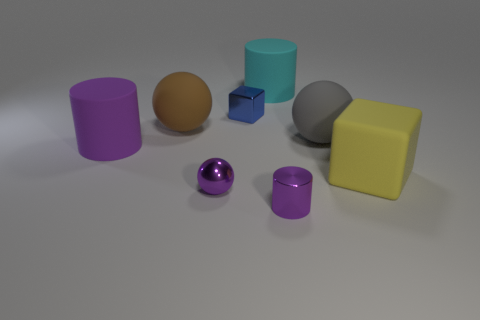Are there an equal number of tiny metal cylinders that are behind the small purple sphere and large gray shiny cubes?
Your answer should be compact. Yes. What number of blocks are behind the ball that is right of the tiny thing right of the small blue metallic thing?
Keep it short and to the point. 1. There is a brown rubber thing; is it the same size as the matte cylinder behind the blue cube?
Your answer should be very brief. Yes. What number of matte spheres are there?
Your response must be concise. 2. There is a purple cylinder right of the blue object; does it have the same size as the metal object behind the large yellow thing?
Make the answer very short. Yes. What is the color of the small thing that is the same shape as the big purple thing?
Ensure brevity in your answer.  Purple. Does the yellow matte thing have the same shape as the brown object?
Offer a very short reply. No. There is a rubber thing that is the same shape as the blue metallic thing; what size is it?
Offer a very short reply. Large. How many large gray spheres have the same material as the large gray thing?
Offer a very short reply. 0. What number of things are large matte cubes or blue shiny spheres?
Make the answer very short. 1. 